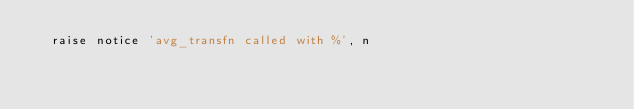<code> <loc_0><loc_0><loc_500><loc_500><_SQL_>	raise notice 'avg_transfn called with %', n
</code> 